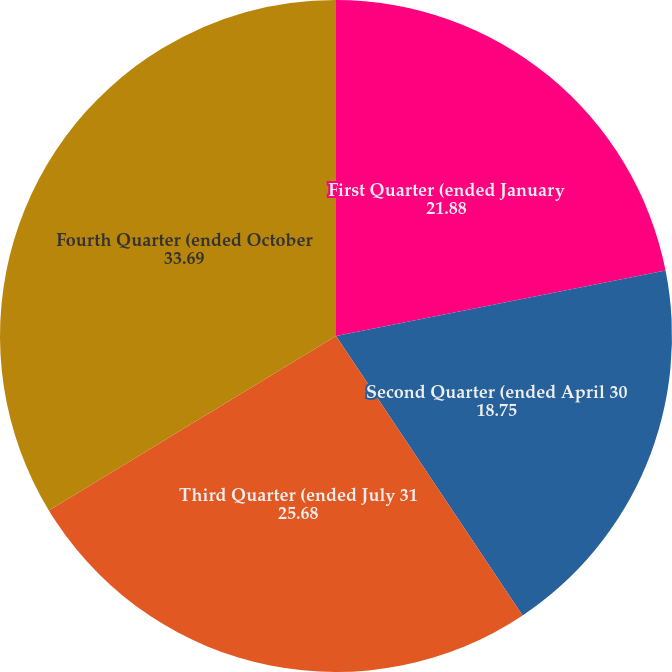<chart> <loc_0><loc_0><loc_500><loc_500><pie_chart><fcel>First Quarter (ended January<fcel>Second Quarter (ended April 30<fcel>Third Quarter (ended July 31<fcel>Fourth Quarter (ended October<nl><fcel>21.88%<fcel>18.75%<fcel>25.68%<fcel>33.69%<nl></chart> 